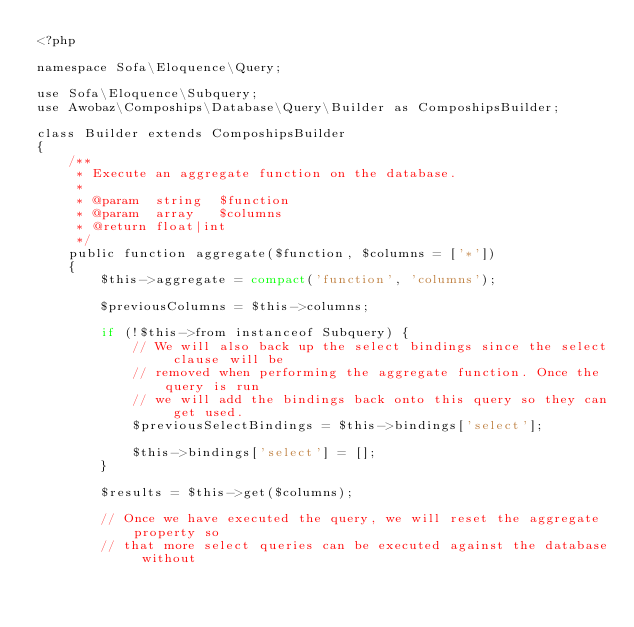Convert code to text. <code><loc_0><loc_0><loc_500><loc_500><_PHP_><?php

namespace Sofa\Eloquence\Query;

use Sofa\Eloquence\Subquery;
use Awobaz\Compoships\Database\Query\Builder as ComposhipsBuilder;

class Builder extends ComposhipsBuilder
{
    /**
     * Execute an aggregate function on the database.
     *
     * @param  string  $function
     * @param  array   $columns
     * @return float|int
     */
    public function aggregate($function, $columns = ['*'])
    {
        $this->aggregate = compact('function', 'columns');

        $previousColumns = $this->columns;

        if (!$this->from instanceof Subquery) {
            // We will also back up the select bindings since the select clause will be
            // removed when performing the aggregate function. Once the query is run
            // we will add the bindings back onto this query so they can get used.
            $previousSelectBindings = $this->bindings['select'];

            $this->bindings['select'] = [];
        }

        $results = $this->get($columns);

        // Once we have executed the query, we will reset the aggregate property so
        // that more select queries can be executed against the database without</code> 